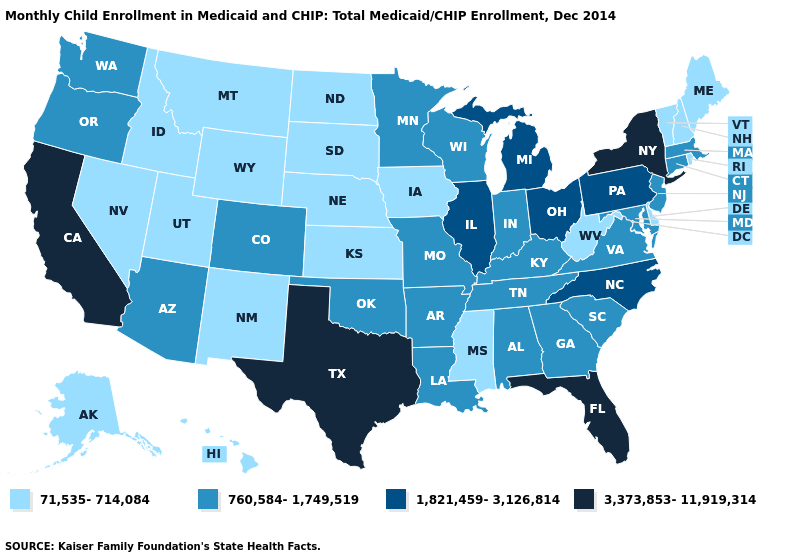Does South Dakota have the highest value in the USA?
Concise answer only. No. Does Illinois have the same value as Mississippi?
Give a very brief answer. No. Name the states that have a value in the range 71,535-714,084?
Keep it brief. Alaska, Delaware, Hawaii, Idaho, Iowa, Kansas, Maine, Mississippi, Montana, Nebraska, Nevada, New Hampshire, New Mexico, North Dakota, Rhode Island, South Dakota, Utah, Vermont, West Virginia, Wyoming. Among the states that border Indiana , does Ohio have the highest value?
Answer briefly. Yes. Does Washington have a higher value than Idaho?
Write a very short answer. Yes. What is the highest value in the South ?
Quick response, please. 3,373,853-11,919,314. Name the states that have a value in the range 760,584-1,749,519?
Answer briefly. Alabama, Arizona, Arkansas, Colorado, Connecticut, Georgia, Indiana, Kentucky, Louisiana, Maryland, Massachusetts, Minnesota, Missouri, New Jersey, Oklahoma, Oregon, South Carolina, Tennessee, Virginia, Washington, Wisconsin. Does Florida have a higher value than Texas?
Answer briefly. No. Among the states that border Oregon , which have the highest value?
Give a very brief answer. California. Which states have the highest value in the USA?
Give a very brief answer. California, Florida, New York, Texas. Name the states that have a value in the range 71,535-714,084?
Give a very brief answer. Alaska, Delaware, Hawaii, Idaho, Iowa, Kansas, Maine, Mississippi, Montana, Nebraska, Nevada, New Hampshire, New Mexico, North Dakota, Rhode Island, South Dakota, Utah, Vermont, West Virginia, Wyoming. What is the lowest value in the USA?
Give a very brief answer. 71,535-714,084. Among the states that border Arkansas , does Mississippi have the lowest value?
Be succinct. Yes. Which states have the highest value in the USA?
Answer briefly. California, Florida, New York, Texas. 